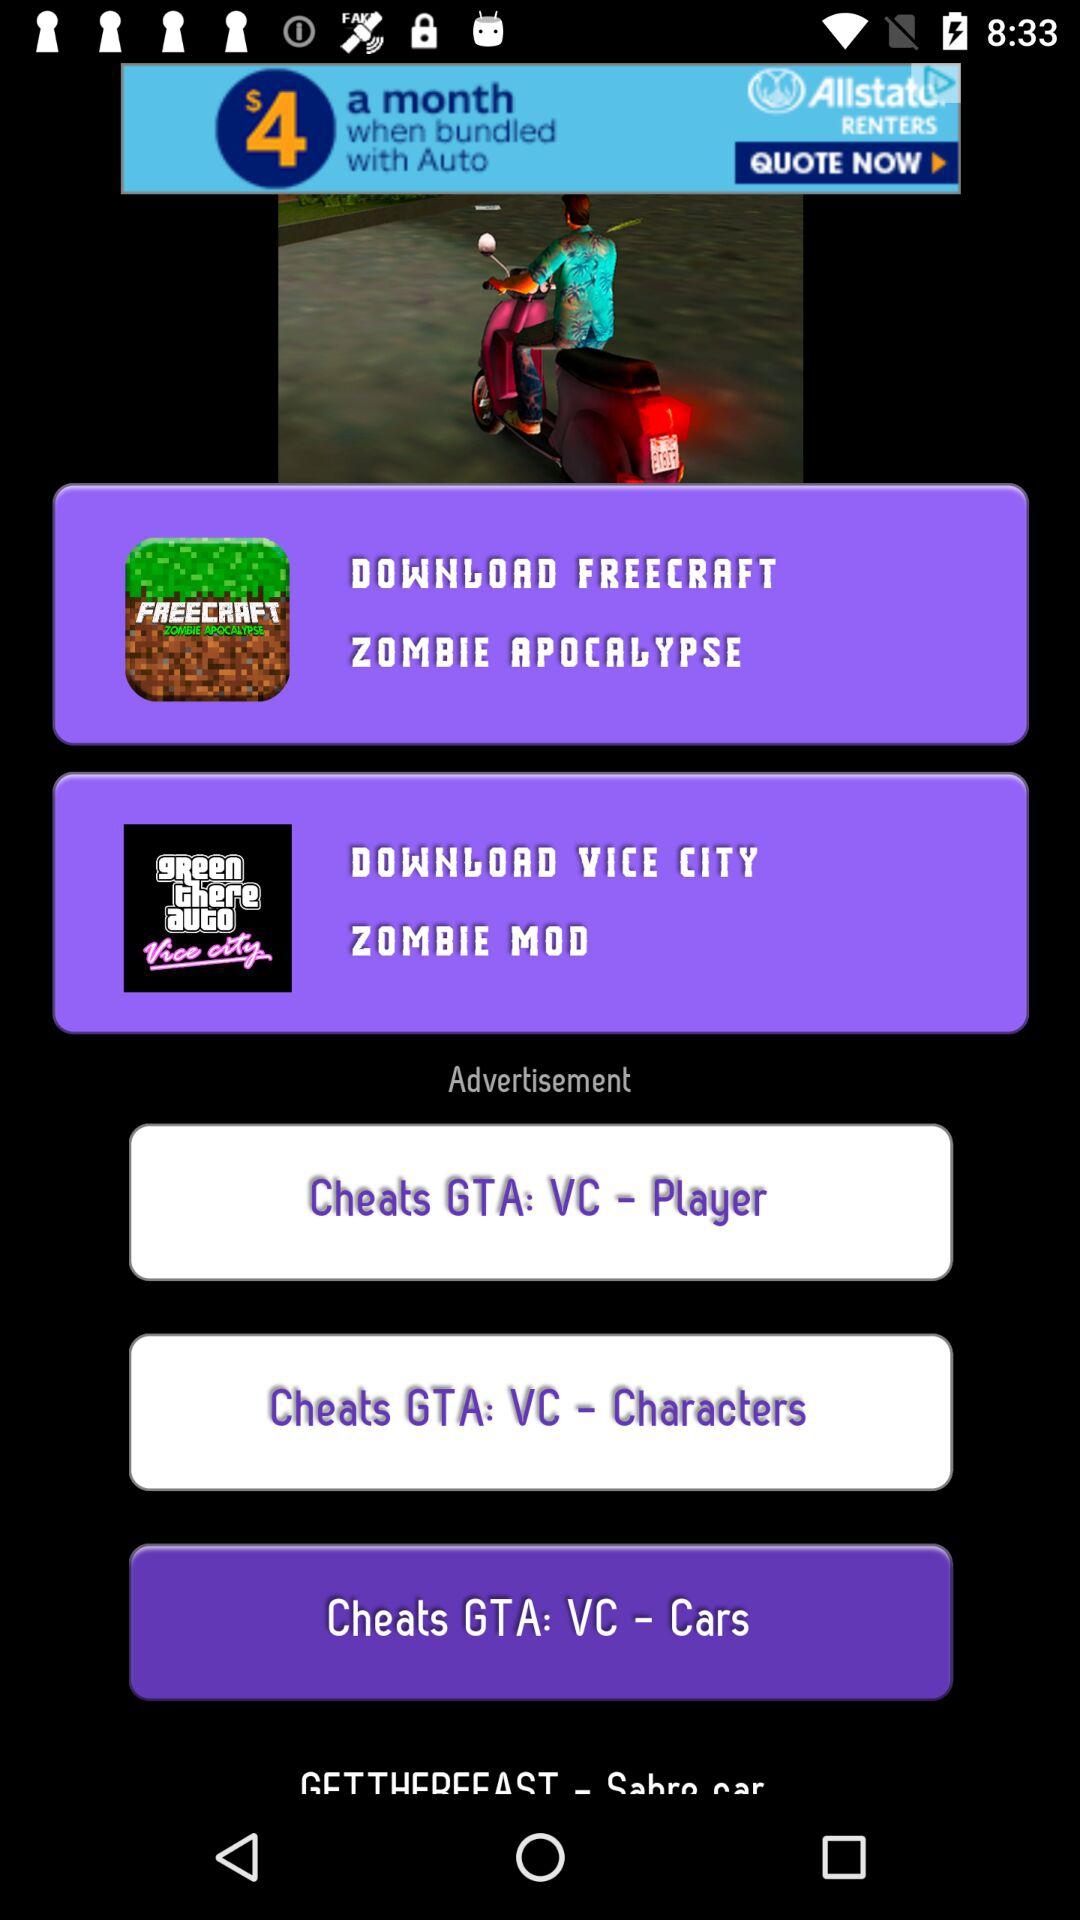How many GTA: VC cheats are there?
Answer the question using a single word or phrase. 3 